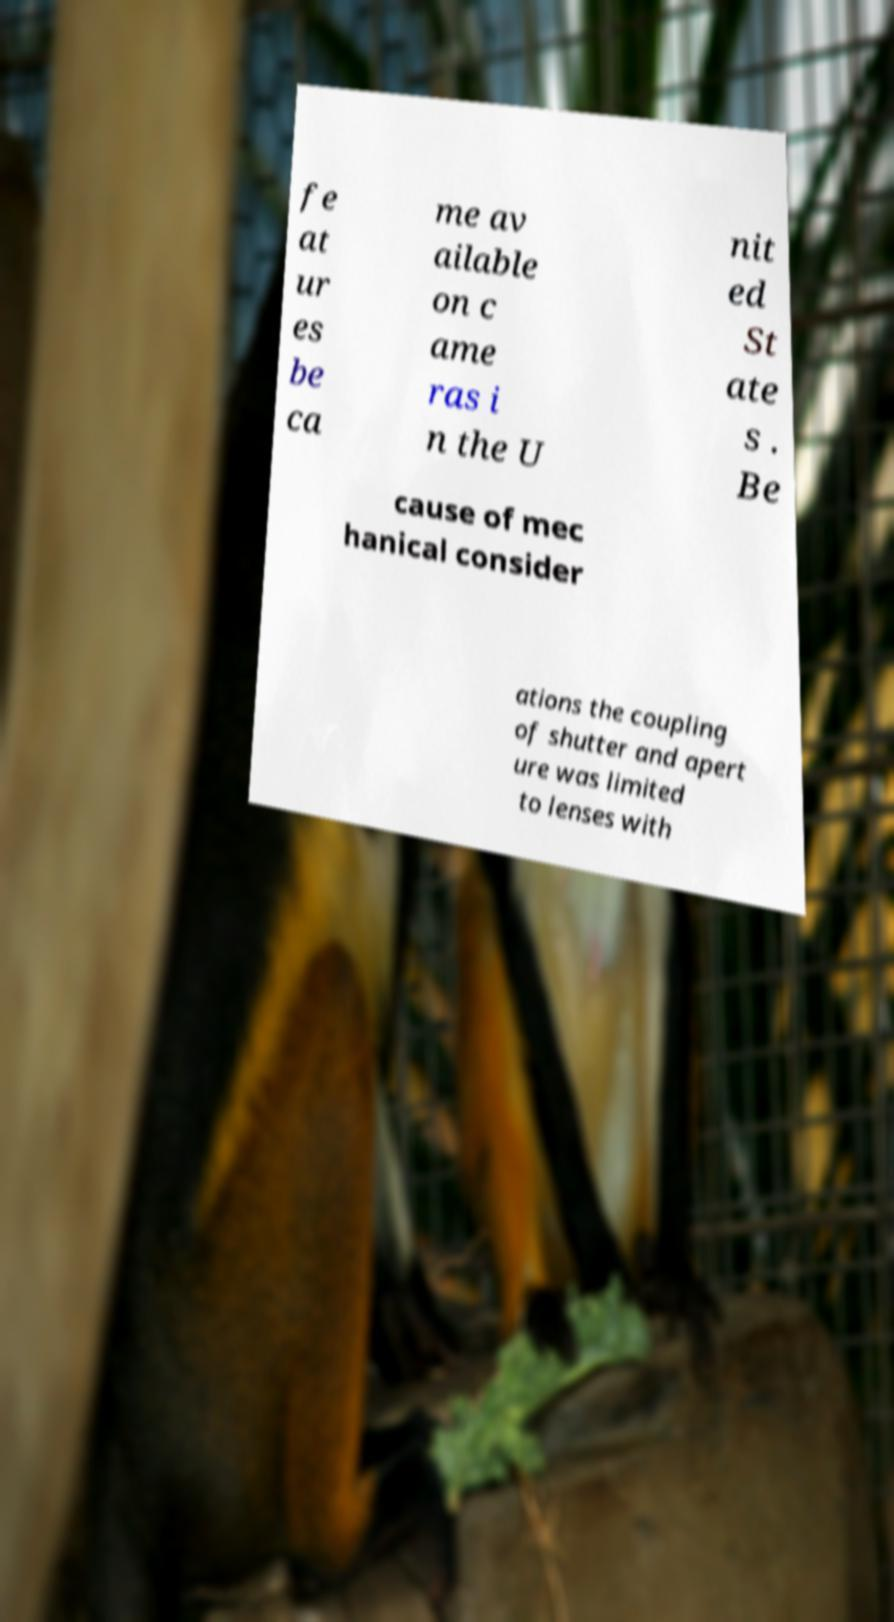For documentation purposes, I need the text within this image transcribed. Could you provide that? fe at ur es be ca me av ailable on c ame ras i n the U nit ed St ate s . Be cause of mec hanical consider ations the coupling of shutter and apert ure was limited to lenses with 